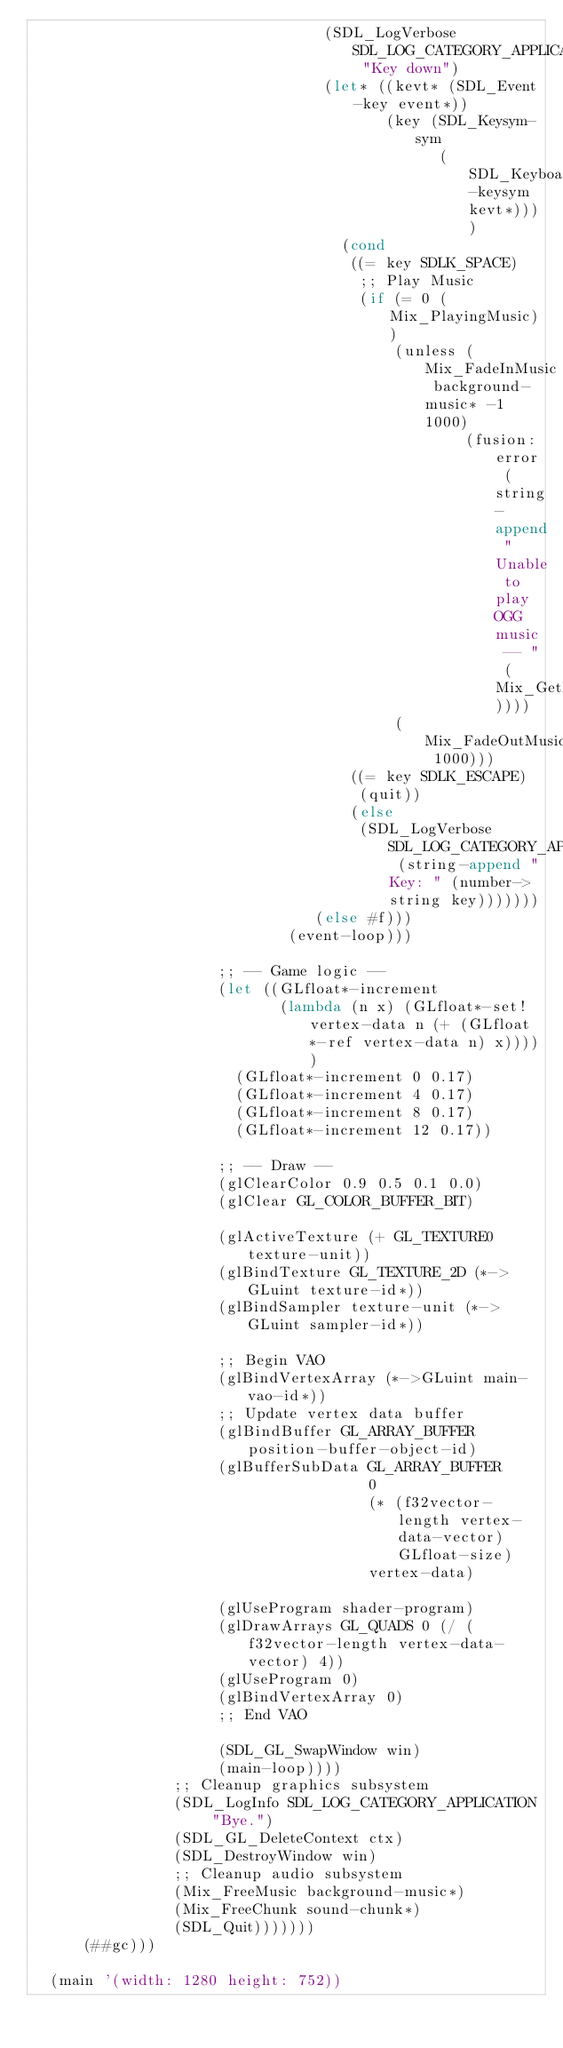Convert code to text. <code><loc_0><loc_0><loc_500><loc_500><_Scheme_>                                 (SDL_LogVerbose SDL_LOG_CATEGORY_APPLICATION "Key down")
                                 (let* ((kevt* (SDL_Event-key event*))
                                        (key (SDL_Keysym-sym
                                              (SDL_KeyboardEvent-keysym kevt*))))
                                   (cond
                                    ((= key SDLK_SPACE)
                                     ;; Play Music
                                     (if (= 0 (Mix_PlayingMusic))
                                         (unless (Mix_FadeInMusic background-music* -1 1000)
                                                 (fusion:error (string-append "Unable to play OGG music -- " (Mix_GetError))))
                                         (Mix_FadeOutMusic 1000)))
                                    ((= key SDLK_ESCAPE)
                                     (quit))
                                    (else
                                     (SDL_LogVerbose SDL_LOG_CATEGORY_APPLICATION (string-append "Key: " (number->string key)))))))
                                (else #f)))
                             (event-loop)))

                     ;; -- Game logic --
                     (let ((GLfloat*-increment
                            (lambda (n x) (GLfloat*-set! vertex-data n (+ (GLfloat*-ref vertex-data n) x)))))
                       (GLfloat*-increment 0 0.17)
                       (GLfloat*-increment 4 0.17)
                       (GLfloat*-increment 8 0.17)
                       (GLfloat*-increment 12 0.17))
                     
                     ;; -- Draw --
                     (glClearColor 0.9 0.5 0.1 0.0)
                     (glClear GL_COLOR_BUFFER_BIT)
                     
                     (glActiveTexture (+ GL_TEXTURE0 texture-unit))
                     (glBindTexture GL_TEXTURE_2D (*->GLuint texture-id*))
                     (glBindSampler texture-unit (*->GLuint sampler-id*))

                     ;; Begin VAO
                     (glBindVertexArray (*->GLuint main-vao-id*))
                     ;; Update vertex data buffer
                     (glBindBuffer GL_ARRAY_BUFFER position-buffer-object-id)
                     (glBufferSubData GL_ARRAY_BUFFER
                                      0
                                      (* (f32vector-length vertex-data-vector) GLfloat-size)
                                      vertex-data)
                     
                     (glUseProgram shader-program)
                     (glDrawArrays GL_QUADS 0 (/ (f32vector-length vertex-data-vector) 4))
                     (glUseProgram 0)
                     (glBindVertexArray 0)
                     ;; End VAO
                     
                     (SDL_GL_SwapWindow win)
                     (main-loop))))
                ;; Cleanup graphics subsystem
                (SDL_LogInfo SDL_LOG_CATEGORY_APPLICATION "Bye.")
                (SDL_GL_DeleteContext ctx)
                (SDL_DestroyWindow win)
                ;; Cleanup audio subsystem
                (Mix_FreeMusic background-music*)
                (Mix_FreeChunk sound-chunk*)
                (SDL_Quit)))))))
      (##gc)))

  (main '(width: 1280 height: 752))
</code> 